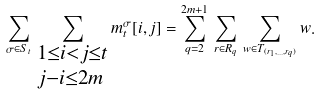Convert formula to latex. <formula><loc_0><loc_0><loc_500><loc_500>\sum _ { \sigma \in S _ { t } } \, \sum _ { \begin{subarray} { 1 } 1 \leq i < j \leq t \\ \\ j - i \leq 2 m \end{subarray} } m _ { t } ^ { \sigma } [ i , j ] = \sum _ { q = 2 } ^ { 2 m + 1 } \, \sum _ { r \in R _ { q } } \, \sum _ { w \in T _ { ( r _ { 1 } , \dots , r _ { q } ) } } w .</formula> 